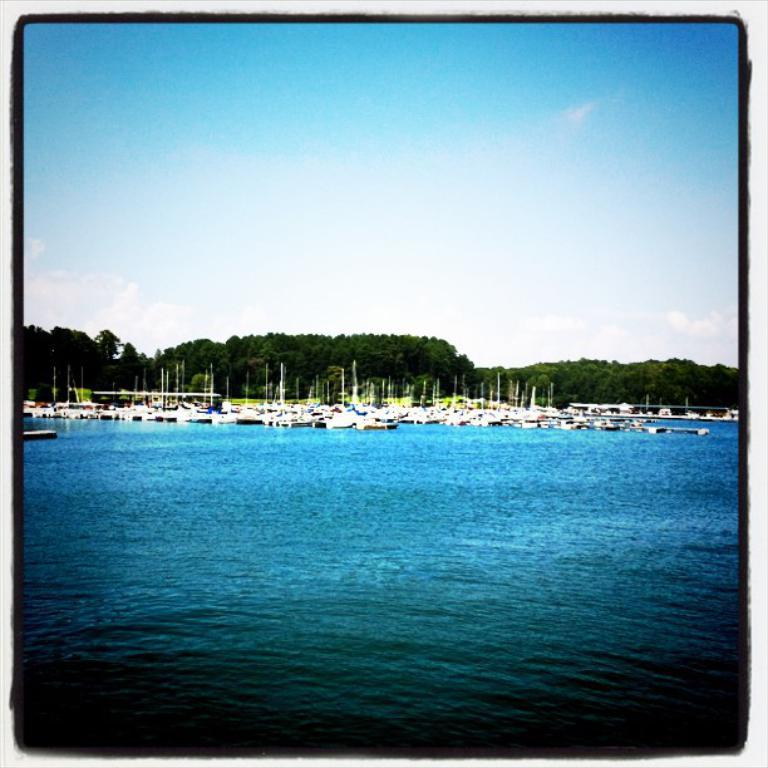What is the main subject of the image? The image contains a photo. What can be seen in the photo? There are many boats in the photo. Where was the photo likely taken? The photo appears to be taken near the ocean. What is visible in the background of the photo? There are trees in the background of the photo. What is visible at the top of the photo? The sky is visible at the top of the photo. What type of hat is the tree wearing in the photo? There is no tree wearing a hat in the photo; trees do not wear hats. What story is being told by the boats in the photo? The photo does not tell a story; it simply depicts many boats near the ocean. 